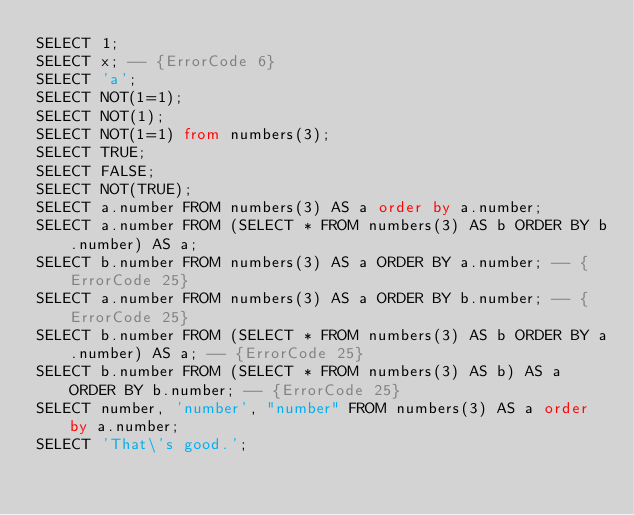<code> <loc_0><loc_0><loc_500><loc_500><_SQL_>SELECT 1;
SELECT x; -- {ErrorCode 6}
SELECT 'a';
SELECT NOT(1=1);
SELECT NOT(1);
SELECT NOT(1=1) from numbers(3);
SELECT TRUE;
SELECT FALSE;
SELECT NOT(TRUE);
SELECT a.number FROM numbers(3) AS a order by a.number;
SELECT a.number FROM (SELECT * FROM numbers(3) AS b ORDER BY b.number) AS a;
SELECT b.number FROM numbers(3) AS a ORDER BY a.number; -- {ErrorCode 25}
SELECT a.number FROM numbers(3) AS a ORDER BY b.number; -- {ErrorCode 25}
SELECT b.number FROM (SELECT * FROM numbers(3) AS b ORDER BY a.number) AS a; -- {ErrorCode 25}
SELECT b.number FROM (SELECT * FROM numbers(3) AS b) AS a ORDER BY b.number; -- {ErrorCode 25}
SELECT number, 'number', "number" FROM numbers(3) AS a order by a.number;
SELECT 'That\'s good.';
</code> 